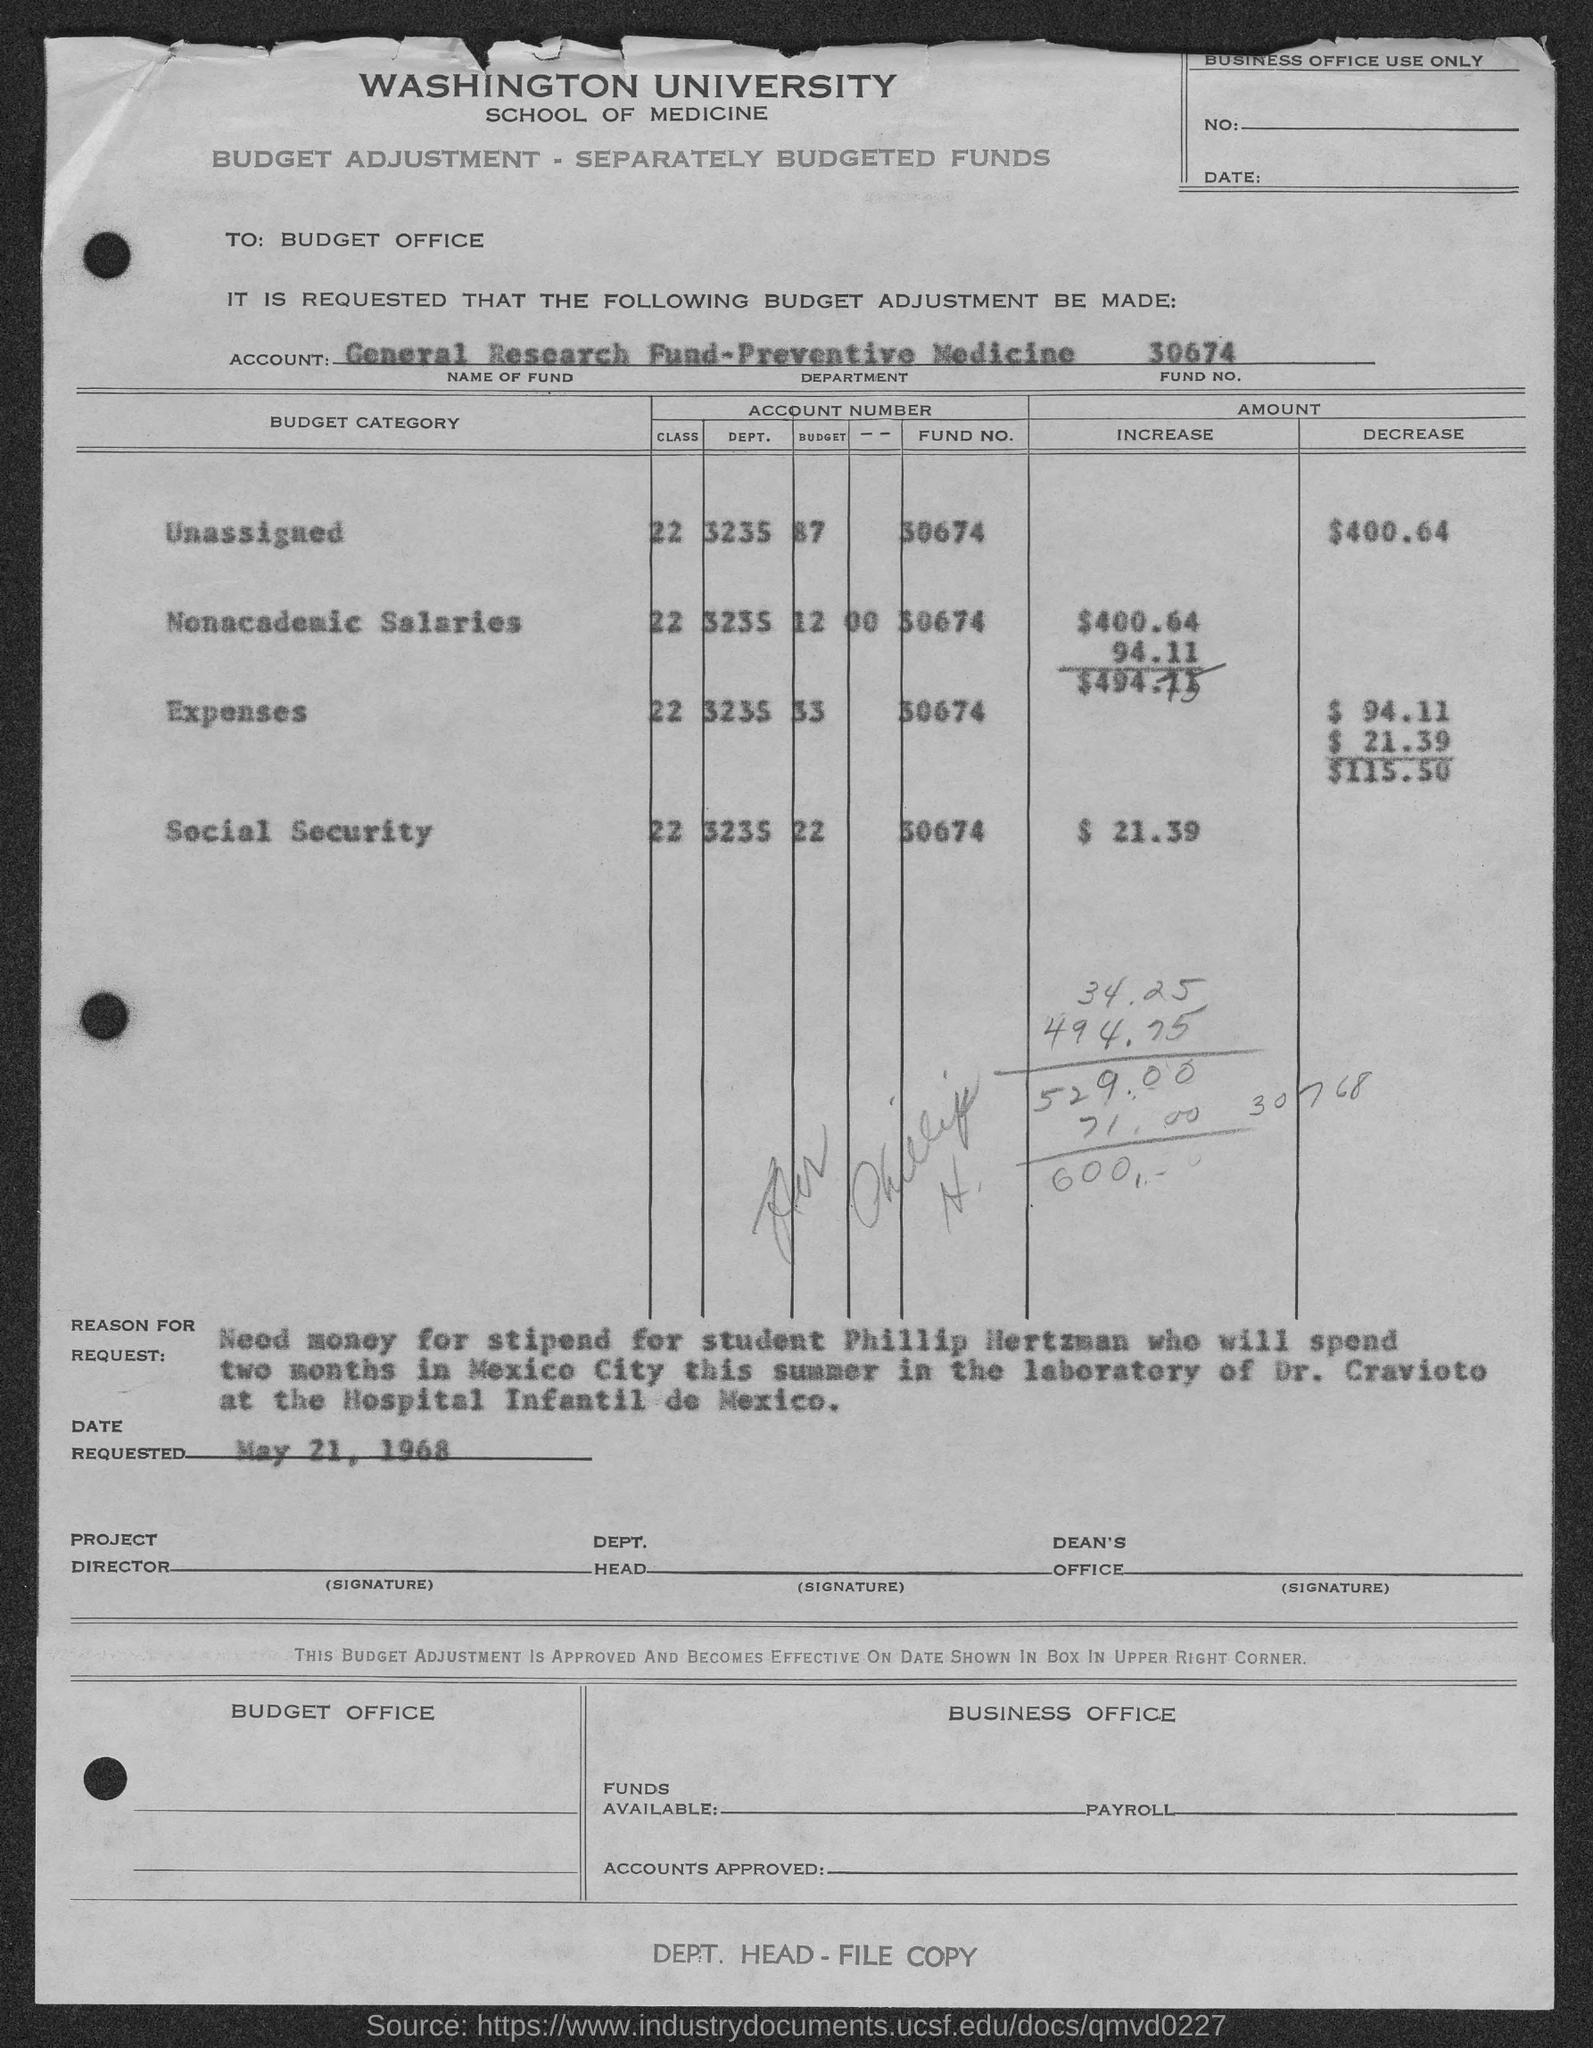To Whom is this letter addressed to?
Your answer should be very brief. Budget Office. What is the Name of fund?
Ensure brevity in your answer.  General Research Fund. What is the Department?
Your response must be concise. Preventive medicine. What is the Fund No.?
Offer a very short reply. 30674. What is the "Unassigned" "Decrease"?
Your response must be concise. $400.64. What is the Social security "increase"?
Offer a terse response. $ 21.39. What is the Date requested?
Your answer should be very brief. May 21, 1968. Who is the stipend for?
Offer a terse response. Phillip Hertzman. 